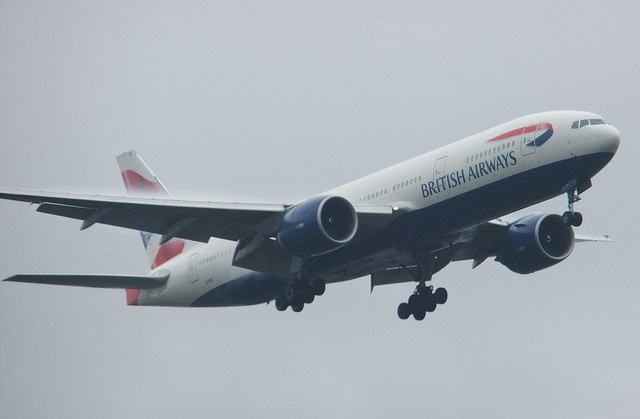Describe the objects in this image and their specific colors. I can see a airplane in darkgray, darkblue, black, and lightgray tones in this image. 